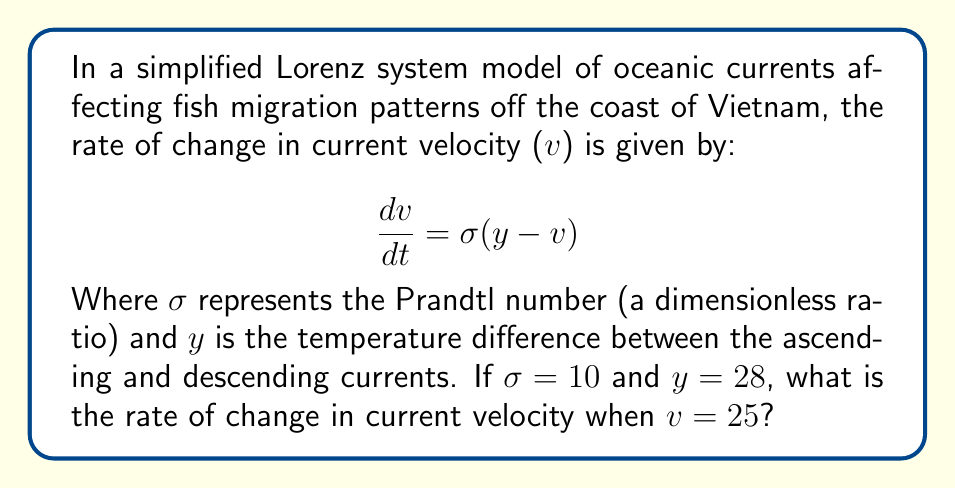Help me with this question. To solve this problem, we'll follow these steps:

1) We are given the Lorenz equation for the rate of change in current velocity:

   $$\frac{dv}{dt} = \sigma(y - v)$$

2) We are provided with the following values:
   $\sigma = 10$ (Prandtl number)
   $y = 28$ (temperature difference)
   $v = 25$ (current velocity)

3) Let's substitute these values into the equation:

   $$\frac{dv}{dt} = 10(28 - 25)$$

4) Simplify the expression inside the parentheses:

   $$\frac{dv}{dt} = 10(3)$$

5) Perform the multiplication:

   $$\frac{dv}{dt} = 30$$

This result indicates that the rate of change in current velocity is 30 units per time unit (the specific units would depend on how velocity and time are measured in this model).
Answer: $30$ 